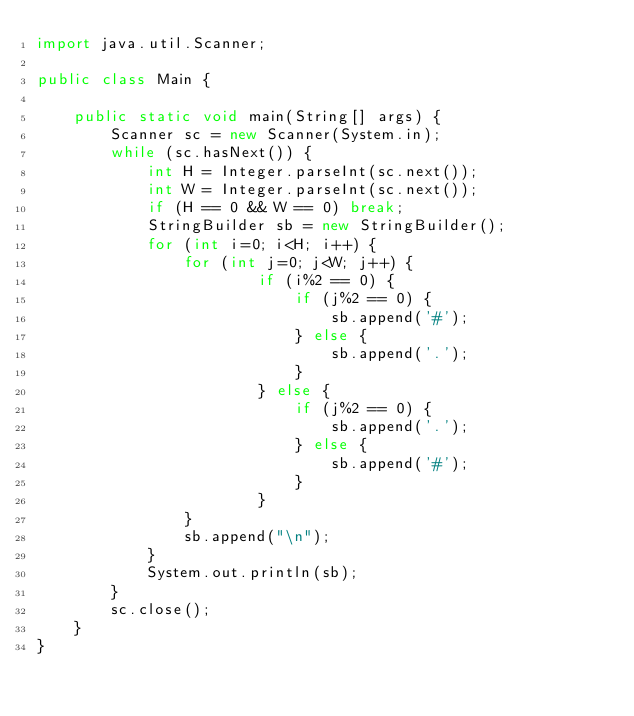Convert code to text. <code><loc_0><loc_0><loc_500><loc_500><_Java_>import java.util.Scanner;

public class Main {

	public static void main(String[] args) {
		Scanner sc = new Scanner(System.in);
		while (sc.hasNext()) {
			int H = Integer.parseInt(sc.next());
			int W = Integer.parseInt(sc.next());
			if (H == 0 && W == 0) break;
			StringBuilder sb = new StringBuilder();
			for (int i=0; i<H; i++) {
				for (int j=0; j<W; j++) {
						if (i%2 == 0) {
							if (j%2 == 0) {
								sb.append('#');
							} else {
								sb.append('.');
							}
						} else {
							if (j%2 == 0) {
								sb.append('.');
							} else {
								sb.append('#');
							}
						}
				}
				sb.append("\n");
			}
			System.out.println(sb);
		}
		sc.close();
	}
}</code> 